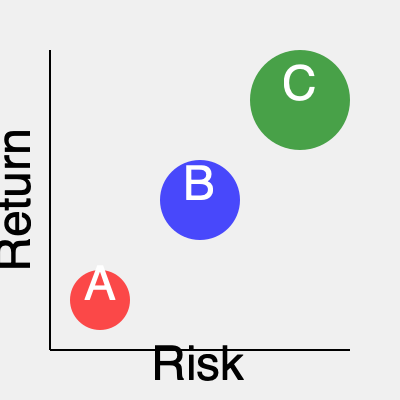Based on the project portfolio management bubble chart shown, which project should be prioritized for resource allocation to maximize strategic value, and why? To interpret this project portfolio management bubble chart and make a strategic decision, we need to consider three key factors:

1. Risk (x-axis): Projects further to the right have higher risk.
2. Return (y-axis): Projects higher on the chart have higher potential returns.
3. Size of the bubble: Larger bubbles typically represent projects with larger budgets or resource requirements.

Analyzing each project:

A. Low risk, low return, small budget
B. Medium risk, medium return, medium budget
C. High risk, high return, large budget

Step-by-step analysis:

1. Risk assessment: Project C has the highest risk, followed by B, then A.
2. Return potential: Project C offers the highest return, followed by B, then A.
3. Resource requirement: Project C requires the most resources, followed by B, then A.

Strategic decision-making:

As a strategic project manager, we should prioritize the project that offers the best balance of risk and return while considering resource constraints. In this case, Project B appears to be the most balanced option:

1. It offers a moderate return with manageable risk.
2. It requires fewer resources than Project C, potentially allowing for a more diversified portfolio.
3. It has a better risk-return profile than Project A.

While Project C offers the highest potential return, its high risk and large resource requirement make it a riskier choice. Project A, although low-risk, doesn't offer significant returns to justify prioritization.
Answer: Project B should be prioritized due to its balanced risk-return profile and moderate resource requirements. 